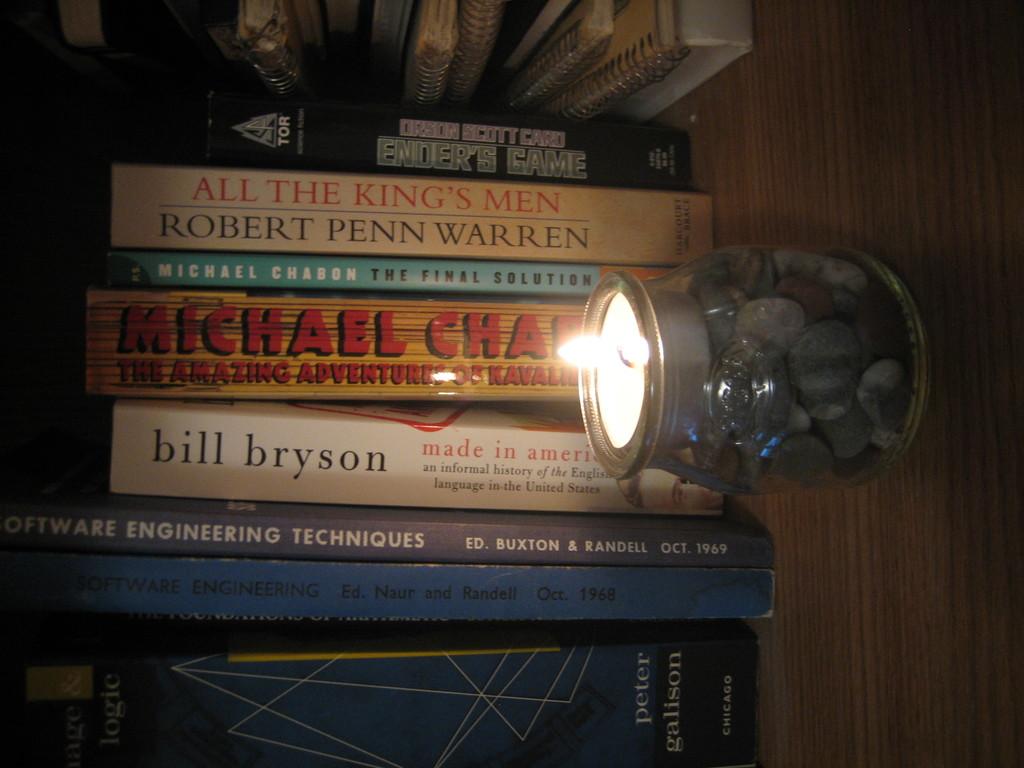Who wrote made in america?
Your answer should be compact. Bill bryson. Who is the author of all the king's men?
Provide a short and direct response. Robert penn warren. 